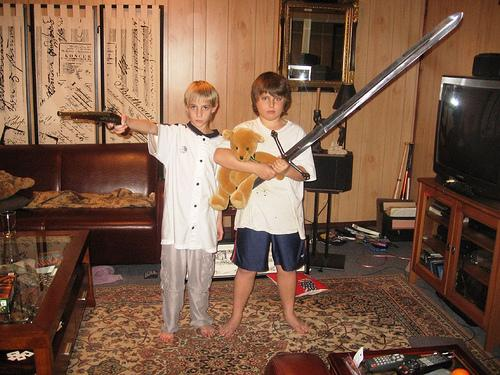What is the boy on the right holding?

Choices:
A) sword
B) shield
C) pumpkin
D) mace sword 